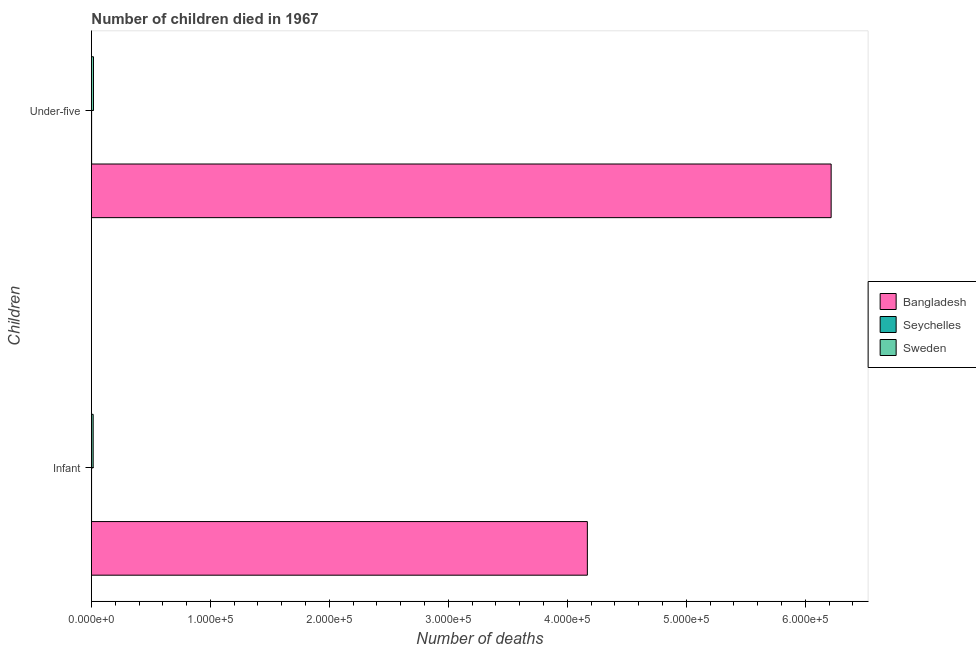Are the number of bars on each tick of the Y-axis equal?
Provide a short and direct response. Yes. How many bars are there on the 1st tick from the bottom?
Provide a short and direct response. 3. What is the label of the 1st group of bars from the top?
Your answer should be compact. Under-five. What is the number of infant deaths in Sweden?
Make the answer very short. 1470. Across all countries, what is the maximum number of under-five deaths?
Your answer should be compact. 6.22e+05. Across all countries, what is the minimum number of infant deaths?
Keep it short and to the point. 115. In which country was the number of infant deaths minimum?
Offer a terse response. Seychelles. What is the total number of infant deaths in the graph?
Give a very brief answer. 4.18e+05. What is the difference between the number of infant deaths in Bangladesh and that in Sweden?
Ensure brevity in your answer.  4.15e+05. What is the difference between the number of under-five deaths in Bangladesh and the number of infant deaths in Seychelles?
Your answer should be compact. 6.22e+05. What is the average number of infant deaths per country?
Give a very brief answer. 1.39e+05. What is the difference between the number of infant deaths and number of under-five deaths in Sweden?
Your response must be concise. -266. What is the ratio of the number of under-five deaths in Seychelles to that in Bangladesh?
Offer a very short reply. 0. Is the number of infant deaths in Bangladesh less than that in Seychelles?
Your response must be concise. No. In how many countries, is the number of under-five deaths greater than the average number of under-five deaths taken over all countries?
Your response must be concise. 1. What does the 2nd bar from the bottom in Infant represents?
Offer a very short reply. Seychelles. How many bars are there?
Your answer should be very brief. 6. Are all the bars in the graph horizontal?
Give a very brief answer. Yes. How many countries are there in the graph?
Keep it short and to the point. 3. Does the graph contain grids?
Offer a terse response. No. What is the title of the graph?
Ensure brevity in your answer.  Number of children died in 1967. What is the label or title of the X-axis?
Keep it short and to the point. Number of deaths. What is the label or title of the Y-axis?
Your answer should be compact. Children. What is the Number of deaths in Bangladesh in Infant?
Make the answer very short. 4.17e+05. What is the Number of deaths of Seychelles in Infant?
Your answer should be compact. 115. What is the Number of deaths in Sweden in Infant?
Your answer should be very brief. 1470. What is the Number of deaths in Bangladesh in Under-five?
Offer a very short reply. 6.22e+05. What is the Number of deaths in Seychelles in Under-five?
Offer a very short reply. 153. What is the Number of deaths in Sweden in Under-five?
Provide a short and direct response. 1736. Across all Children, what is the maximum Number of deaths of Bangladesh?
Keep it short and to the point. 6.22e+05. Across all Children, what is the maximum Number of deaths of Seychelles?
Provide a short and direct response. 153. Across all Children, what is the maximum Number of deaths of Sweden?
Make the answer very short. 1736. Across all Children, what is the minimum Number of deaths in Bangladesh?
Provide a succinct answer. 4.17e+05. Across all Children, what is the minimum Number of deaths in Seychelles?
Your response must be concise. 115. Across all Children, what is the minimum Number of deaths in Sweden?
Provide a succinct answer. 1470. What is the total Number of deaths of Bangladesh in the graph?
Give a very brief answer. 1.04e+06. What is the total Number of deaths in Seychelles in the graph?
Your response must be concise. 268. What is the total Number of deaths of Sweden in the graph?
Offer a terse response. 3206. What is the difference between the Number of deaths of Bangladesh in Infant and that in Under-five?
Ensure brevity in your answer.  -2.05e+05. What is the difference between the Number of deaths of Seychelles in Infant and that in Under-five?
Offer a terse response. -38. What is the difference between the Number of deaths of Sweden in Infant and that in Under-five?
Provide a succinct answer. -266. What is the difference between the Number of deaths in Bangladesh in Infant and the Number of deaths in Seychelles in Under-five?
Make the answer very short. 4.17e+05. What is the difference between the Number of deaths of Bangladesh in Infant and the Number of deaths of Sweden in Under-five?
Keep it short and to the point. 4.15e+05. What is the difference between the Number of deaths of Seychelles in Infant and the Number of deaths of Sweden in Under-five?
Give a very brief answer. -1621. What is the average Number of deaths in Bangladesh per Children?
Offer a very short reply. 5.19e+05. What is the average Number of deaths in Seychelles per Children?
Ensure brevity in your answer.  134. What is the average Number of deaths of Sweden per Children?
Make the answer very short. 1603. What is the difference between the Number of deaths in Bangladesh and Number of deaths in Seychelles in Infant?
Provide a short and direct response. 4.17e+05. What is the difference between the Number of deaths of Bangladesh and Number of deaths of Sweden in Infant?
Make the answer very short. 4.15e+05. What is the difference between the Number of deaths of Seychelles and Number of deaths of Sweden in Infant?
Offer a terse response. -1355. What is the difference between the Number of deaths in Bangladesh and Number of deaths in Seychelles in Under-five?
Your answer should be very brief. 6.22e+05. What is the difference between the Number of deaths of Bangladesh and Number of deaths of Sweden in Under-five?
Provide a short and direct response. 6.20e+05. What is the difference between the Number of deaths in Seychelles and Number of deaths in Sweden in Under-five?
Provide a short and direct response. -1583. What is the ratio of the Number of deaths in Bangladesh in Infant to that in Under-five?
Your answer should be compact. 0.67. What is the ratio of the Number of deaths of Seychelles in Infant to that in Under-five?
Give a very brief answer. 0.75. What is the ratio of the Number of deaths of Sweden in Infant to that in Under-five?
Offer a terse response. 0.85. What is the difference between the highest and the second highest Number of deaths in Bangladesh?
Offer a very short reply. 2.05e+05. What is the difference between the highest and the second highest Number of deaths in Seychelles?
Offer a very short reply. 38. What is the difference between the highest and the second highest Number of deaths of Sweden?
Ensure brevity in your answer.  266. What is the difference between the highest and the lowest Number of deaths of Bangladesh?
Ensure brevity in your answer.  2.05e+05. What is the difference between the highest and the lowest Number of deaths of Sweden?
Your response must be concise. 266. 